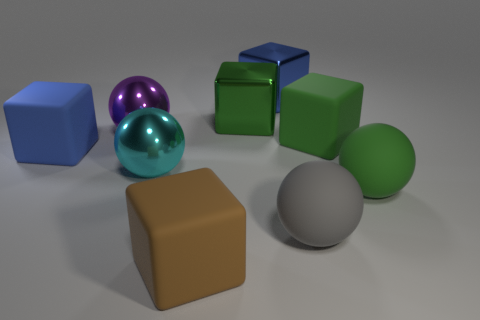There is a purple ball that is the same size as the green metal thing; what is its material?
Ensure brevity in your answer.  Metal. How many objects are large green matte spheres or purple metallic spheres?
Ensure brevity in your answer.  2. How many big objects are both right of the green metal object and behind the large purple metal thing?
Provide a short and direct response. 1. Is the number of big purple metallic things that are in front of the green rubber ball less than the number of small green spheres?
Your answer should be compact. No. There is a gray object that is the same size as the brown rubber cube; what is its shape?
Make the answer very short. Sphere. Is the purple ball the same size as the blue metallic object?
Offer a terse response. Yes. What number of objects are tiny red rubber spheres or green things in front of the large purple metal object?
Keep it short and to the point. 2. Are there fewer large blue shiny cubes left of the brown matte object than big blue objects right of the large gray matte ball?
Your answer should be compact. No. What number of other objects are there of the same material as the purple thing?
Keep it short and to the point. 3. There is a metal cube that is left of the big blue metallic thing; are there any cyan spheres that are behind it?
Ensure brevity in your answer.  No. 